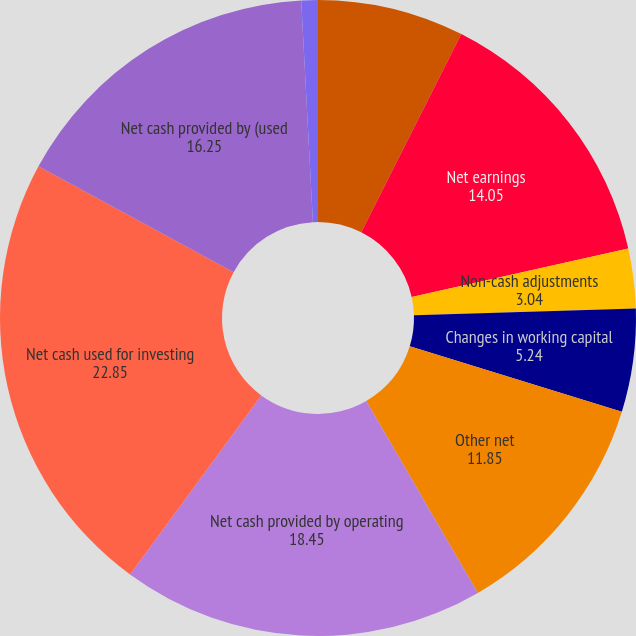<chart> <loc_0><loc_0><loc_500><loc_500><pie_chart><fcel>Cash and cash equivalents at<fcel>Net earnings<fcel>Non-cash adjustments<fcel>Changes in working capital<fcel>Other net<fcel>Net cash provided by operating<fcel>Net cash used for investing<fcel>Net cash provided by (used<fcel>Net change in cash and cash<nl><fcel>7.44%<fcel>14.05%<fcel>3.04%<fcel>5.24%<fcel>11.85%<fcel>18.45%<fcel>22.85%<fcel>16.25%<fcel>0.84%<nl></chart> 